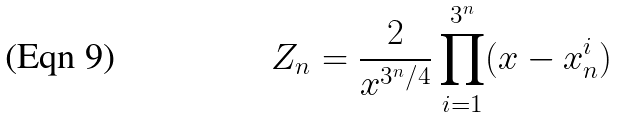<formula> <loc_0><loc_0><loc_500><loc_500>Z _ { n } = \frac { 2 } { x ^ { 3 ^ { n } / 4 } } \prod _ { i = 1 } ^ { 3 ^ { n } } ( x - x _ { n } ^ { i } )</formula> 